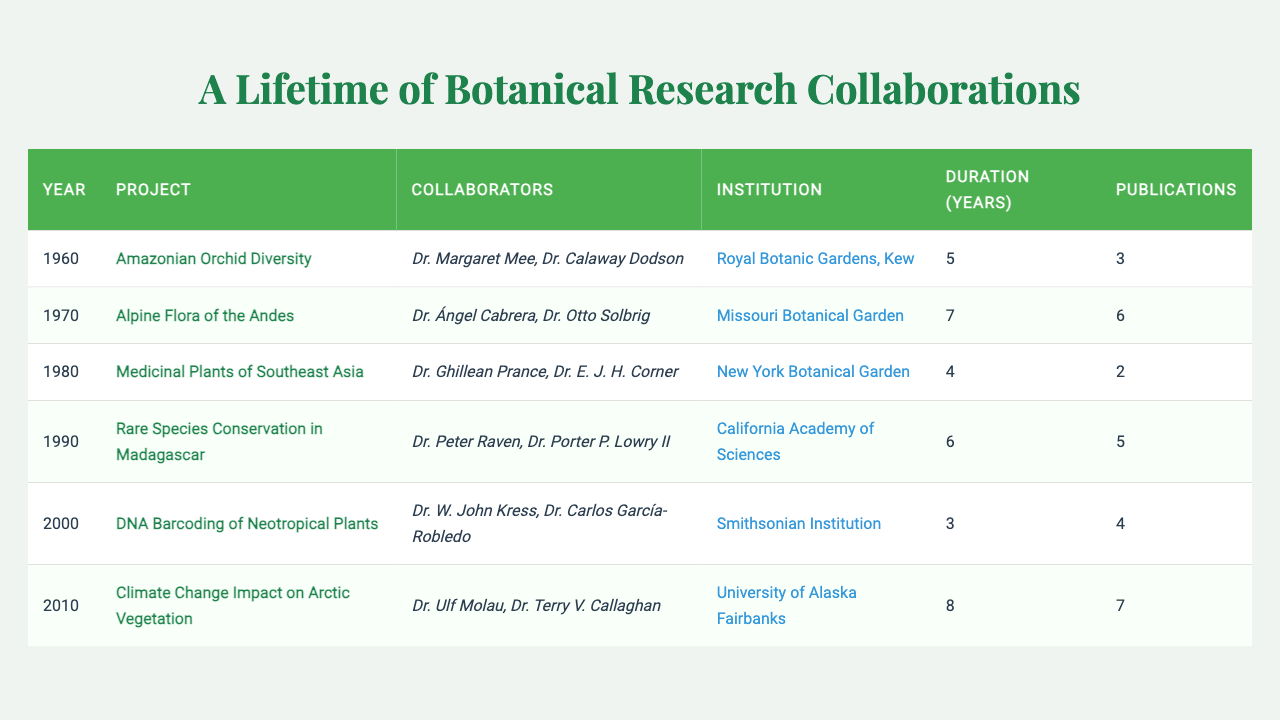What is the duration of the "Rare Species Conservation in Madagascar" project? The table indicates that the duration listed under "Rare Species Conservation in Madagascar" is 6 years.
Answer: 6 years Who collaborated on the "Medicinal Plants of Southeast Asia" project? Referring to the table, the collaborators listed for this project are Dr. Ghillean Prance and Dr. E. J. H. Corner.
Answer: Dr. Ghillean Prance and Dr. E. J. H. Corner How many publications resulted from the "Amazonian Orchid Diversity" project? The table states that the "Amazonian Orchid Diversity" project resulted in 3 publications.
Answer: 3 What was the average duration of the projects listed in the table? The total duration of all projects is (5 + 7 + 4 + 6 + 3 + 8) = 33 years. There are 6 projects, so the average duration is 33/6 = 5.5 years.
Answer: 5.5 years Which project had the highest number of publications? By comparing the publications listed, "Climate Change Impact on Arctic Vegetation" has the highest count at 7 publications.
Answer: "Climate Change Impact on Arctic Vegetation" Did the "DNA Barcoding of Neotropical Plants" project have fewer publications than the "Medicinal Plants of Southeast Asia"? The "DNA Barcoding of Neotropical Plants" project had 4 publications, while the "Medicinal Plants of Southeast Asia" had 2. Thus, it is true that DNA Barcoding had more publications.
Answer: No How many years did the collaboration with the maximum duration take place? The project "Climate Change Impact on Arctic Vegetation" lasted for 8 years, which is the maximum duration listed among the projects.
Answer: 8 years What can be inferred about the trend in the number of publications from 1960 to 2010? If we list the publications for each project, we have 3, 6, 2, 5, 4, and 7. By analyzing this, we can see that while some years had higher counts, the trend is not strictly increasing or decreasing; it's varied. Thus, the publications do not follow a straightforward trend.
Answer: Varied trend Which institution collaborated on the "Alpine Flora of the Andes" project? According to the table, the "Alpine Flora of the Andes" project was in collaboration with the Missouri Botanical Garden.
Answer: Missouri Botanical Garden Calculate the total number of publications across all projects. By summing the number of publications listed (3 + 6 + 2 + 5 + 4 + 7), we find that the total number of publications is 27.
Answer: 27 Was there a project in 1990? Referring to the table, the projects from the years listed only go up to 2010. Therefore, we confirm that there was indeed a project listed for 1990, namely "Rare Species Conservation in Madagascar."
Answer: Yes 